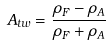<formula> <loc_0><loc_0><loc_500><loc_500>A _ { t w } = \frac { \rho _ { F } - \rho _ { A } } { \rho _ { F } + \rho _ { A } }</formula> 